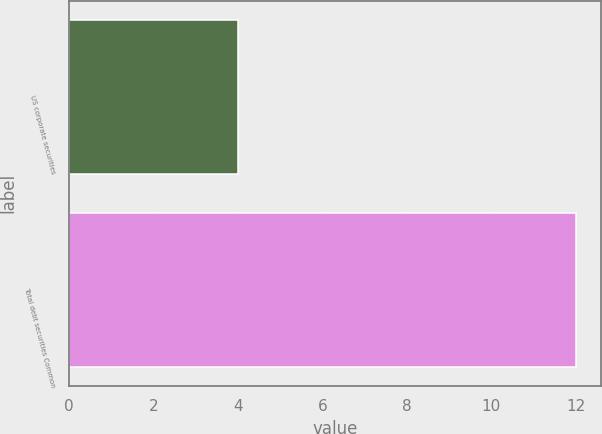Convert chart to OTSL. <chart><loc_0><loc_0><loc_500><loc_500><bar_chart><fcel>US corporate securities<fcel>Total debt securities Common<nl><fcel>4<fcel>12<nl></chart> 